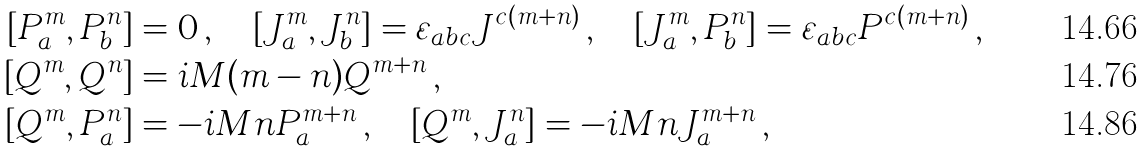<formula> <loc_0><loc_0><loc_500><loc_500>[ P _ { a } ^ { m } , P _ { b } ^ { n } ] & = 0 \, , \quad [ J _ { a } ^ { m } , J _ { b } ^ { n } ] = \varepsilon _ { a b c } J ^ { c ( m + n ) } \, , \quad [ J _ { a } ^ { m } , P _ { b } ^ { n } ] = \varepsilon _ { a b c } P ^ { c ( m + n ) } \, , \\ [ Q ^ { m } , Q ^ { n } ] & = i M ( m - n ) Q ^ { m + n } \, , \\ [ Q ^ { m } , P _ { a } ^ { n } ] & = - i M n P _ { a } ^ { m + n } \, , \quad [ Q ^ { m } , J _ { a } ^ { n } ] = - i M n J _ { a } ^ { m + n } \, ,</formula> 